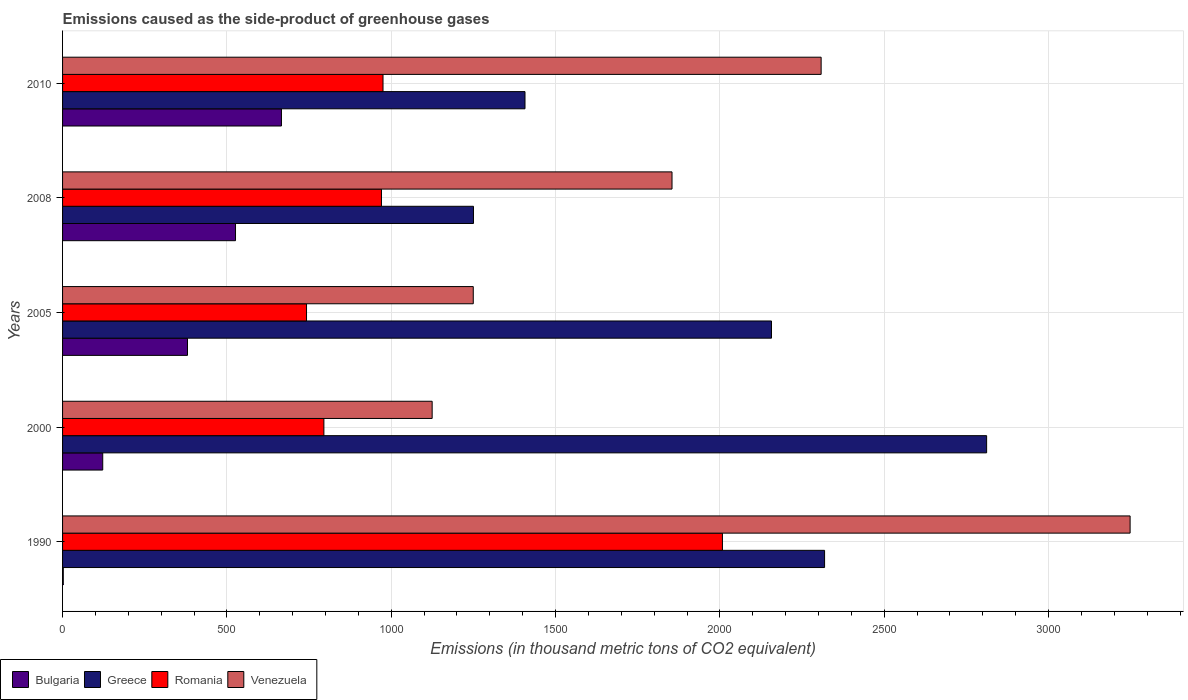How many different coloured bars are there?
Keep it short and to the point. 4. What is the label of the 4th group of bars from the top?
Ensure brevity in your answer.  2000. In how many cases, is the number of bars for a given year not equal to the number of legend labels?
Give a very brief answer. 0. What is the emissions caused as the side-product of greenhouse gases in Greece in 1990?
Offer a very short reply. 2318.5. Across all years, what is the maximum emissions caused as the side-product of greenhouse gases in Greece?
Make the answer very short. 2811.5. Across all years, what is the minimum emissions caused as the side-product of greenhouse gases in Venezuela?
Provide a succinct answer. 1124.5. In which year was the emissions caused as the side-product of greenhouse gases in Bulgaria minimum?
Your answer should be compact. 1990. What is the total emissions caused as the side-product of greenhouse gases in Romania in the graph?
Give a very brief answer. 5490.4. What is the difference between the emissions caused as the side-product of greenhouse gases in Romania in 2000 and that in 2008?
Provide a succinct answer. -175.2. What is the difference between the emissions caused as the side-product of greenhouse gases in Bulgaria in 1990 and the emissions caused as the side-product of greenhouse gases in Venezuela in 2000?
Make the answer very short. -1122.3. What is the average emissions caused as the side-product of greenhouse gases in Venezuela per year?
Offer a very short reply. 1956.9. In the year 2010, what is the difference between the emissions caused as the side-product of greenhouse gases in Romania and emissions caused as the side-product of greenhouse gases in Bulgaria?
Offer a very short reply. 309. What is the ratio of the emissions caused as the side-product of greenhouse gases in Bulgaria in 1990 to that in 2008?
Provide a short and direct response. 0. Is the emissions caused as the side-product of greenhouse gases in Venezuela in 2008 less than that in 2010?
Your answer should be very brief. Yes. What is the difference between the highest and the second highest emissions caused as the side-product of greenhouse gases in Romania?
Offer a very short reply. 1032.7. What is the difference between the highest and the lowest emissions caused as the side-product of greenhouse gases in Bulgaria?
Your answer should be very brief. 663.8. Is the sum of the emissions caused as the side-product of greenhouse gases in Romania in 2005 and 2008 greater than the maximum emissions caused as the side-product of greenhouse gases in Bulgaria across all years?
Ensure brevity in your answer.  Yes. Is it the case that in every year, the sum of the emissions caused as the side-product of greenhouse gases in Venezuela and emissions caused as the side-product of greenhouse gases in Greece is greater than the sum of emissions caused as the side-product of greenhouse gases in Romania and emissions caused as the side-product of greenhouse gases in Bulgaria?
Offer a very short reply. Yes. What does the 3rd bar from the top in 1990 represents?
Ensure brevity in your answer.  Greece. What does the 4th bar from the bottom in 2005 represents?
Offer a very short reply. Venezuela. How many bars are there?
Give a very brief answer. 20. Are all the bars in the graph horizontal?
Offer a very short reply. Yes. Are the values on the major ticks of X-axis written in scientific E-notation?
Keep it short and to the point. No. Where does the legend appear in the graph?
Provide a short and direct response. Bottom left. How many legend labels are there?
Make the answer very short. 4. How are the legend labels stacked?
Your answer should be compact. Horizontal. What is the title of the graph?
Your answer should be compact. Emissions caused as the side-product of greenhouse gases. Does "Fiji" appear as one of the legend labels in the graph?
Offer a terse response. No. What is the label or title of the X-axis?
Your answer should be very brief. Emissions (in thousand metric tons of CO2 equivalent). What is the label or title of the Y-axis?
Give a very brief answer. Years. What is the Emissions (in thousand metric tons of CO2 equivalent) of Greece in 1990?
Your answer should be very brief. 2318.5. What is the Emissions (in thousand metric tons of CO2 equivalent) of Romania in 1990?
Provide a short and direct response. 2007.7. What is the Emissions (in thousand metric tons of CO2 equivalent) of Venezuela in 1990?
Ensure brevity in your answer.  3248.1. What is the Emissions (in thousand metric tons of CO2 equivalent) in Bulgaria in 2000?
Offer a terse response. 122.2. What is the Emissions (in thousand metric tons of CO2 equivalent) in Greece in 2000?
Your response must be concise. 2811.5. What is the Emissions (in thousand metric tons of CO2 equivalent) of Romania in 2000?
Your answer should be compact. 795.1. What is the Emissions (in thousand metric tons of CO2 equivalent) in Venezuela in 2000?
Provide a short and direct response. 1124.5. What is the Emissions (in thousand metric tons of CO2 equivalent) of Bulgaria in 2005?
Make the answer very short. 380.1. What is the Emissions (in thousand metric tons of CO2 equivalent) in Greece in 2005?
Keep it short and to the point. 2157. What is the Emissions (in thousand metric tons of CO2 equivalent) of Romania in 2005?
Your answer should be compact. 742.3. What is the Emissions (in thousand metric tons of CO2 equivalent) in Venezuela in 2005?
Keep it short and to the point. 1249.6. What is the Emissions (in thousand metric tons of CO2 equivalent) of Bulgaria in 2008?
Provide a succinct answer. 526.2. What is the Emissions (in thousand metric tons of CO2 equivalent) in Greece in 2008?
Provide a succinct answer. 1250.2. What is the Emissions (in thousand metric tons of CO2 equivalent) of Romania in 2008?
Offer a terse response. 970.3. What is the Emissions (in thousand metric tons of CO2 equivalent) in Venezuela in 2008?
Your response must be concise. 1854.3. What is the Emissions (in thousand metric tons of CO2 equivalent) in Bulgaria in 2010?
Make the answer very short. 666. What is the Emissions (in thousand metric tons of CO2 equivalent) in Greece in 2010?
Offer a very short reply. 1407. What is the Emissions (in thousand metric tons of CO2 equivalent) of Romania in 2010?
Your answer should be very brief. 975. What is the Emissions (in thousand metric tons of CO2 equivalent) of Venezuela in 2010?
Your response must be concise. 2308. Across all years, what is the maximum Emissions (in thousand metric tons of CO2 equivalent) of Bulgaria?
Keep it short and to the point. 666. Across all years, what is the maximum Emissions (in thousand metric tons of CO2 equivalent) of Greece?
Keep it short and to the point. 2811.5. Across all years, what is the maximum Emissions (in thousand metric tons of CO2 equivalent) in Romania?
Your answer should be compact. 2007.7. Across all years, what is the maximum Emissions (in thousand metric tons of CO2 equivalent) of Venezuela?
Give a very brief answer. 3248.1. Across all years, what is the minimum Emissions (in thousand metric tons of CO2 equivalent) in Greece?
Provide a short and direct response. 1250.2. Across all years, what is the minimum Emissions (in thousand metric tons of CO2 equivalent) of Romania?
Offer a very short reply. 742.3. Across all years, what is the minimum Emissions (in thousand metric tons of CO2 equivalent) of Venezuela?
Offer a very short reply. 1124.5. What is the total Emissions (in thousand metric tons of CO2 equivalent) of Bulgaria in the graph?
Offer a very short reply. 1696.7. What is the total Emissions (in thousand metric tons of CO2 equivalent) in Greece in the graph?
Give a very brief answer. 9944.2. What is the total Emissions (in thousand metric tons of CO2 equivalent) in Romania in the graph?
Offer a very short reply. 5490.4. What is the total Emissions (in thousand metric tons of CO2 equivalent) in Venezuela in the graph?
Make the answer very short. 9784.5. What is the difference between the Emissions (in thousand metric tons of CO2 equivalent) of Bulgaria in 1990 and that in 2000?
Offer a terse response. -120. What is the difference between the Emissions (in thousand metric tons of CO2 equivalent) in Greece in 1990 and that in 2000?
Keep it short and to the point. -493. What is the difference between the Emissions (in thousand metric tons of CO2 equivalent) of Romania in 1990 and that in 2000?
Provide a short and direct response. 1212.6. What is the difference between the Emissions (in thousand metric tons of CO2 equivalent) of Venezuela in 1990 and that in 2000?
Ensure brevity in your answer.  2123.6. What is the difference between the Emissions (in thousand metric tons of CO2 equivalent) in Bulgaria in 1990 and that in 2005?
Provide a succinct answer. -377.9. What is the difference between the Emissions (in thousand metric tons of CO2 equivalent) of Greece in 1990 and that in 2005?
Offer a very short reply. 161.5. What is the difference between the Emissions (in thousand metric tons of CO2 equivalent) of Romania in 1990 and that in 2005?
Your answer should be very brief. 1265.4. What is the difference between the Emissions (in thousand metric tons of CO2 equivalent) in Venezuela in 1990 and that in 2005?
Provide a succinct answer. 1998.5. What is the difference between the Emissions (in thousand metric tons of CO2 equivalent) of Bulgaria in 1990 and that in 2008?
Your answer should be very brief. -524. What is the difference between the Emissions (in thousand metric tons of CO2 equivalent) in Greece in 1990 and that in 2008?
Provide a short and direct response. 1068.3. What is the difference between the Emissions (in thousand metric tons of CO2 equivalent) in Romania in 1990 and that in 2008?
Your answer should be very brief. 1037.4. What is the difference between the Emissions (in thousand metric tons of CO2 equivalent) of Venezuela in 1990 and that in 2008?
Ensure brevity in your answer.  1393.8. What is the difference between the Emissions (in thousand metric tons of CO2 equivalent) in Bulgaria in 1990 and that in 2010?
Ensure brevity in your answer.  -663.8. What is the difference between the Emissions (in thousand metric tons of CO2 equivalent) in Greece in 1990 and that in 2010?
Your answer should be compact. 911.5. What is the difference between the Emissions (in thousand metric tons of CO2 equivalent) in Romania in 1990 and that in 2010?
Offer a very short reply. 1032.7. What is the difference between the Emissions (in thousand metric tons of CO2 equivalent) in Venezuela in 1990 and that in 2010?
Your response must be concise. 940.1. What is the difference between the Emissions (in thousand metric tons of CO2 equivalent) of Bulgaria in 2000 and that in 2005?
Your answer should be very brief. -257.9. What is the difference between the Emissions (in thousand metric tons of CO2 equivalent) of Greece in 2000 and that in 2005?
Provide a short and direct response. 654.5. What is the difference between the Emissions (in thousand metric tons of CO2 equivalent) of Romania in 2000 and that in 2005?
Your response must be concise. 52.8. What is the difference between the Emissions (in thousand metric tons of CO2 equivalent) in Venezuela in 2000 and that in 2005?
Provide a short and direct response. -125.1. What is the difference between the Emissions (in thousand metric tons of CO2 equivalent) of Bulgaria in 2000 and that in 2008?
Provide a succinct answer. -404. What is the difference between the Emissions (in thousand metric tons of CO2 equivalent) in Greece in 2000 and that in 2008?
Your answer should be compact. 1561.3. What is the difference between the Emissions (in thousand metric tons of CO2 equivalent) in Romania in 2000 and that in 2008?
Offer a terse response. -175.2. What is the difference between the Emissions (in thousand metric tons of CO2 equivalent) of Venezuela in 2000 and that in 2008?
Give a very brief answer. -729.8. What is the difference between the Emissions (in thousand metric tons of CO2 equivalent) of Bulgaria in 2000 and that in 2010?
Your answer should be very brief. -543.8. What is the difference between the Emissions (in thousand metric tons of CO2 equivalent) of Greece in 2000 and that in 2010?
Offer a very short reply. 1404.5. What is the difference between the Emissions (in thousand metric tons of CO2 equivalent) of Romania in 2000 and that in 2010?
Offer a very short reply. -179.9. What is the difference between the Emissions (in thousand metric tons of CO2 equivalent) of Venezuela in 2000 and that in 2010?
Keep it short and to the point. -1183.5. What is the difference between the Emissions (in thousand metric tons of CO2 equivalent) of Bulgaria in 2005 and that in 2008?
Give a very brief answer. -146.1. What is the difference between the Emissions (in thousand metric tons of CO2 equivalent) of Greece in 2005 and that in 2008?
Your response must be concise. 906.8. What is the difference between the Emissions (in thousand metric tons of CO2 equivalent) in Romania in 2005 and that in 2008?
Give a very brief answer. -228. What is the difference between the Emissions (in thousand metric tons of CO2 equivalent) in Venezuela in 2005 and that in 2008?
Provide a succinct answer. -604.7. What is the difference between the Emissions (in thousand metric tons of CO2 equivalent) of Bulgaria in 2005 and that in 2010?
Make the answer very short. -285.9. What is the difference between the Emissions (in thousand metric tons of CO2 equivalent) in Greece in 2005 and that in 2010?
Keep it short and to the point. 750. What is the difference between the Emissions (in thousand metric tons of CO2 equivalent) in Romania in 2005 and that in 2010?
Your answer should be very brief. -232.7. What is the difference between the Emissions (in thousand metric tons of CO2 equivalent) in Venezuela in 2005 and that in 2010?
Your answer should be compact. -1058.4. What is the difference between the Emissions (in thousand metric tons of CO2 equivalent) in Bulgaria in 2008 and that in 2010?
Your response must be concise. -139.8. What is the difference between the Emissions (in thousand metric tons of CO2 equivalent) of Greece in 2008 and that in 2010?
Provide a short and direct response. -156.8. What is the difference between the Emissions (in thousand metric tons of CO2 equivalent) in Romania in 2008 and that in 2010?
Provide a short and direct response. -4.7. What is the difference between the Emissions (in thousand metric tons of CO2 equivalent) of Venezuela in 2008 and that in 2010?
Keep it short and to the point. -453.7. What is the difference between the Emissions (in thousand metric tons of CO2 equivalent) of Bulgaria in 1990 and the Emissions (in thousand metric tons of CO2 equivalent) of Greece in 2000?
Keep it short and to the point. -2809.3. What is the difference between the Emissions (in thousand metric tons of CO2 equivalent) of Bulgaria in 1990 and the Emissions (in thousand metric tons of CO2 equivalent) of Romania in 2000?
Your answer should be compact. -792.9. What is the difference between the Emissions (in thousand metric tons of CO2 equivalent) in Bulgaria in 1990 and the Emissions (in thousand metric tons of CO2 equivalent) in Venezuela in 2000?
Your response must be concise. -1122.3. What is the difference between the Emissions (in thousand metric tons of CO2 equivalent) in Greece in 1990 and the Emissions (in thousand metric tons of CO2 equivalent) in Romania in 2000?
Ensure brevity in your answer.  1523.4. What is the difference between the Emissions (in thousand metric tons of CO2 equivalent) of Greece in 1990 and the Emissions (in thousand metric tons of CO2 equivalent) of Venezuela in 2000?
Your response must be concise. 1194. What is the difference between the Emissions (in thousand metric tons of CO2 equivalent) in Romania in 1990 and the Emissions (in thousand metric tons of CO2 equivalent) in Venezuela in 2000?
Keep it short and to the point. 883.2. What is the difference between the Emissions (in thousand metric tons of CO2 equivalent) in Bulgaria in 1990 and the Emissions (in thousand metric tons of CO2 equivalent) in Greece in 2005?
Provide a succinct answer. -2154.8. What is the difference between the Emissions (in thousand metric tons of CO2 equivalent) of Bulgaria in 1990 and the Emissions (in thousand metric tons of CO2 equivalent) of Romania in 2005?
Your answer should be very brief. -740.1. What is the difference between the Emissions (in thousand metric tons of CO2 equivalent) in Bulgaria in 1990 and the Emissions (in thousand metric tons of CO2 equivalent) in Venezuela in 2005?
Your answer should be very brief. -1247.4. What is the difference between the Emissions (in thousand metric tons of CO2 equivalent) of Greece in 1990 and the Emissions (in thousand metric tons of CO2 equivalent) of Romania in 2005?
Provide a succinct answer. 1576.2. What is the difference between the Emissions (in thousand metric tons of CO2 equivalent) in Greece in 1990 and the Emissions (in thousand metric tons of CO2 equivalent) in Venezuela in 2005?
Make the answer very short. 1068.9. What is the difference between the Emissions (in thousand metric tons of CO2 equivalent) in Romania in 1990 and the Emissions (in thousand metric tons of CO2 equivalent) in Venezuela in 2005?
Offer a terse response. 758.1. What is the difference between the Emissions (in thousand metric tons of CO2 equivalent) in Bulgaria in 1990 and the Emissions (in thousand metric tons of CO2 equivalent) in Greece in 2008?
Offer a terse response. -1248. What is the difference between the Emissions (in thousand metric tons of CO2 equivalent) of Bulgaria in 1990 and the Emissions (in thousand metric tons of CO2 equivalent) of Romania in 2008?
Provide a succinct answer. -968.1. What is the difference between the Emissions (in thousand metric tons of CO2 equivalent) in Bulgaria in 1990 and the Emissions (in thousand metric tons of CO2 equivalent) in Venezuela in 2008?
Your answer should be compact. -1852.1. What is the difference between the Emissions (in thousand metric tons of CO2 equivalent) in Greece in 1990 and the Emissions (in thousand metric tons of CO2 equivalent) in Romania in 2008?
Provide a short and direct response. 1348.2. What is the difference between the Emissions (in thousand metric tons of CO2 equivalent) in Greece in 1990 and the Emissions (in thousand metric tons of CO2 equivalent) in Venezuela in 2008?
Make the answer very short. 464.2. What is the difference between the Emissions (in thousand metric tons of CO2 equivalent) in Romania in 1990 and the Emissions (in thousand metric tons of CO2 equivalent) in Venezuela in 2008?
Provide a short and direct response. 153.4. What is the difference between the Emissions (in thousand metric tons of CO2 equivalent) in Bulgaria in 1990 and the Emissions (in thousand metric tons of CO2 equivalent) in Greece in 2010?
Provide a short and direct response. -1404.8. What is the difference between the Emissions (in thousand metric tons of CO2 equivalent) of Bulgaria in 1990 and the Emissions (in thousand metric tons of CO2 equivalent) of Romania in 2010?
Ensure brevity in your answer.  -972.8. What is the difference between the Emissions (in thousand metric tons of CO2 equivalent) of Bulgaria in 1990 and the Emissions (in thousand metric tons of CO2 equivalent) of Venezuela in 2010?
Make the answer very short. -2305.8. What is the difference between the Emissions (in thousand metric tons of CO2 equivalent) of Greece in 1990 and the Emissions (in thousand metric tons of CO2 equivalent) of Romania in 2010?
Offer a very short reply. 1343.5. What is the difference between the Emissions (in thousand metric tons of CO2 equivalent) of Greece in 1990 and the Emissions (in thousand metric tons of CO2 equivalent) of Venezuela in 2010?
Provide a short and direct response. 10.5. What is the difference between the Emissions (in thousand metric tons of CO2 equivalent) of Romania in 1990 and the Emissions (in thousand metric tons of CO2 equivalent) of Venezuela in 2010?
Make the answer very short. -300.3. What is the difference between the Emissions (in thousand metric tons of CO2 equivalent) of Bulgaria in 2000 and the Emissions (in thousand metric tons of CO2 equivalent) of Greece in 2005?
Your answer should be compact. -2034.8. What is the difference between the Emissions (in thousand metric tons of CO2 equivalent) of Bulgaria in 2000 and the Emissions (in thousand metric tons of CO2 equivalent) of Romania in 2005?
Your answer should be compact. -620.1. What is the difference between the Emissions (in thousand metric tons of CO2 equivalent) of Bulgaria in 2000 and the Emissions (in thousand metric tons of CO2 equivalent) of Venezuela in 2005?
Keep it short and to the point. -1127.4. What is the difference between the Emissions (in thousand metric tons of CO2 equivalent) in Greece in 2000 and the Emissions (in thousand metric tons of CO2 equivalent) in Romania in 2005?
Make the answer very short. 2069.2. What is the difference between the Emissions (in thousand metric tons of CO2 equivalent) of Greece in 2000 and the Emissions (in thousand metric tons of CO2 equivalent) of Venezuela in 2005?
Provide a short and direct response. 1561.9. What is the difference between the Emissions (in thousand metric tons of CO2 equivalent) of Romania in 2000 and the Emissions (in thousand metric tons of CO2 equivalent) of Venezuela in 2005?
Offer a very short reply. -454.5. What is the difference between the Emissions (in thousand metric tons of CO2 equivalent) of Bulgaria in 2000 and the Emissions (in thousand metric tons of CO2 equivalent) of Greece in 2008?
Make the answer very short. -1128. What is the difference between the Emissions (in thousand metric tons of CO2 equivalent) in Bulgaria in 2000 and the Emissions (in thousand metric tons of CO2 equivalent) in Romania in 2008?
Provide a short and direct response. -848.1. What is the difference between the Emissions (in thousand metric tons of CO2 equivalent) of Bulgaria in 2000 and the Emissions (in thousand metric tons of CO2 equivalent) of Venezuela in 2008?
Make the answer very short. -1732.1. What is the difference between the Emissions (in thousand metric tons of CO2 equivalent) in Greece in 2000 and the Emissions (in thousand metric tons of CO2 equivalent) in Romania in 2008?
Your response must be concise. 1841.2. What is the difference between the Emissions (in thousand metric tons of CO2 equivalent) of Greece in 2000 and the Emissions (in thousand metric tons of CO2 equivalent) of Venezuela in 2008?
Ensure brevity in your answer.  957.2. What is the difference between the Emissions (in thousand metric tons of CO2 equivalent) of Romania in 2000 and the Emissions (in thousand metric tons of CO2 equivalent) of Venezuela in 2008?
Keep it short and to the point. -1059.2. What is the difference between the Emissions (in thousand metric tons of CO2 equivalent) in Bulgaria in 2000 and the Emissions (in thousand metric tons of CO2 equivalent) in Greece in 2010?
Offer a terse response. -1284.8. What is the difference between the Emissions (in thousand metric tons of CO2 equivalent) in Bulgaria in 2000 and the Emissions (in thousand metric tons of CO2 equivalent) in Romania in 2010?
Your answer should be very brief. -852.8. What is the difference between the Emissions (in thousand metric tons of CO2 equivalent) in Bulgaria in 2000 and the Emissions (in thousand metric tons of CO2 equivalent) in Venezuela in 2010?
Provide a succinct answer. -2185.8. What is the difference between the Emissions (in thousand metric tons of CO2 equivalent) in Greece in 2000 and the Emissions (in thousand metric tons of CO2 equivalent) in Romania in 2010?
Offer a very short reply. 1836.5. What is the difference between the Emissions (in thousand metric tons of CO2 equivalent) in Greece in 2000 and the Emissions (in thousand metric tons of CO2 equivalent) in Venezuela in 2010?
Your answer should be very brief. 503.5. What is the difference between the Emissions (in thousand metric tons of CO2 equivalent) of Romania in 2000 and the Emissions (in thousand metric tons of CO2 equivalent) of Venezuela in 2010?
Your answer should be compact. -1512.9. What is the difference between the Emissions (in thousand metric tons of CO2 equivalent) in Bulgaria in 2005 and the Emissions (in thousand metric tons of CO2 equivalent) in Greece in 2008?
Your answer should be very brief. -870.1. What is the difference between the Emissions (in thousand metric tons of CO2 equivalent) in Bulgaria in 2005 and the Emissions (in thousand metric tons of CO2 equivalent) in Romania in 2008?
Offer a terse response. -590.2. What is the difference between the Emissions (in thousand metric tons of CO2 equivalent) of Bulgaria in 2005 and the Emissions (in thousand metric tons of CO2 equivalent) of Venezuela in 2008?
Your response must be concise. -1474.2. What is the difference between the Emissions (in thousand metric tons of CO2 equivalent) in Greece in 2005 and the Emissions (in thousand metric tons of CO2 equivalent) in Romania in 2008?
Your answer should be very brief. 1186.7. What is the difference between the Emissions (in thousand metric tons of CO2 equivalent) of Greece in 2005 and the Emissions (in thousand metric tons of CO2 equivalent) of Venezuela in 2008?
Give a very brief answer. 302.7. What is the difference between the Emissions (in thousand metric tons of CO2 equivalent) of Romania in 2005 and the Emissions (in thousand metric tons of CO2 equivalent) of Venezuela in 2008?
Offer a terse response. -1112. What is the difference between the Emissions (in thousand metric tons of CO2 equivalent) in Bulgaria in 2005 and the Emissions (in thousand metric tons of CO2 equivalent) in Greece in 2010?
Keep it short and to the point. -1026.9. What is the difference between the Emissions (in thousand metric tons of CO2 equivalent) of Bulgaria in 2005 and the Emissions (in thousand metric tons of CO2 equivalent) of Romania in 2010?
Give a very brief answer. -594.9. What is the difference between the Emissions (in thousand metric tons of CO2 equivalent) in Bulgaria in 2005 and the Emissions (in thousand metric tons of CO2 equivalent) in Venezuela in 2010?
Your response must be concise. -1927.9. What is the difference between the Emissions (in thousand metric tons of CO2 equivalent) of Greece in 2005 and the Emissions (in thousand metric tons of CO2 equivalent) of Romania in 2010?
Give a very brief answer. 1182. What is the difference between the Emissions (in thousand metric tons of CO2 equivalent) of Greece in 2005 and the Emissions (in thousand metric tons of CO2 equivalent) of Venezuela in 2010?
Keep it short and to the point. -151. What is the difference between the Emissions (in thousand metric tons of CO2 equivalent) of Romania in 2005 and the Emissions (in thousand metric tons of CO2 equivalent) of Venezuela in 2010?
Offer a terse response. -1565.7. What is the difference between the Emissions (in thousand metric tons of CO2 equivalent) of Bulgaria in 2008 and the Emissions (in thousand metric tons of CO2 equivalent) of Greece in 2010?
Make the answer very short. -880.8. What is the difference between the Emissions (in thousand metric tons of CO2 equivalent) of Bulgaria in 2008 and the Emissions (in thousand metric tons of CO2 equivalent) of Romania in 2010?
Give a very brief answer. -448.8. What is the difference between the Emissions (in thousand metric tons of CO2 equivalent) of Bulgaria in 2008 and the Emissions (in thousand metric tons of CO2 equivalent) of Venezuela in 2010?
Your response must be concise. -1781.8. What is the difference between the Emissions (in thousand metric tons of CO2 equivalent) in Greece in 2008 and the Emissions (in thousand metric tons of CO2 equivalent) in Romania in 2010?
Give a very brief answer. 275.2. What is the difference between the Emissions (in thousand metric tons of CO2 equivalent) of Greece in 2008 and the Emissions (in thousand metric tons of CO2 equivalent) of Venezuela in 2010?
Provide a succinct answer. -1057.8. What is the difference between the Emissions (in thousand metric tons of CO2 equivalent) in Romania in 2008 and the Emissions (in thousand metric tons of CO2 equivalent) in Venezuela in 2010?
Your answer should be very brief. -1337.7. What is the average Emissions (in thousand metric tons of CO2 equivalent) in Bulgaria per year?
Your answer should be very brief. 339.34. What is the average Emissions (in thousand metric tons of CO2 equivalent) in Greece per year?
Keep it short and to the point. 1988.84. What is the average Emissions (in thousand metric tons of CO2 equivalent) of Romania per year?
Give a very brief answer. 1098.08. What is the average Emissions (in thousand metric tons of CO2 equivalent) in Venezuela per year?
Your response must be concise. 1956.9. In the year 1990, what is the difference between the Emissions (in thousand metric tons of CO2 equivalent) of Bulgaria and Emissions (in thousand metric tons of CO2 equivalent) of Greece?
Offer a very short reply. -2316.3. In the year 1990, what is the difference between the Emissions (in thousand metric tons of CO2 equivalent) of Bulgaria and Emissions (in thousand metric tons of CO2 equivalent) of Romania?
Make the answer very short. -2005.5. In the year 1990, what is the difference between the Emissions (in thousand metric tons of CO2 equivalent) of Bulgaria and Emissions (in thousand metric tons of CO2 equivalent) of Venezuela?
Keep it short and to the point. -3245.9. In the year 1990, what is the difference between the Emissions (in thousand metric tons of CO2 equivalent) of Greece and Emissions (in thousand metric tons of CO2 equivalent) of Romania?
Offer a very short reply. 310.8. In the year 1990, what is the difference between the Emissions (in thousand metric tons of CO2 equivalent) of Greece and Emissions (in thousand metric tons of CO2 equivalent) of Venezuela?
Keep it short and to the point. -929.6. In the year 1990, what is the difference between the Emissions (in thousand metric tons of CO2 equivalent) of Romania and Emissions (in thousand metric tons of CO2 equivalent) of Venezuela?
Your answer should be compact. -1240.4. In the year 2000, what is the difference between the Emissions (in thousand metric tons of CO2 equivalent) in Bulgaria and Emissions (in thousand metric tons of CO2 equivalent) in Greece?
Make the answer very short. -2689.3. In the year 2000, what is the difference between the Emissions (in thousand metric tons of CO2 equivalent) in Bulgaria and Emissions (in thousand metric tons of CO2 equivalent) in Romania?
Give a very brief answer. -672.9. In the year 2000, what is the difference between the Emissions (in thousand metric tons of CO2 equivalent) of Bulgaria and Emissions (in thousand metric tons of CO2 equivalent) of Venezuela?
Provide a succinct answer. -1002.3. In the year 2000, what is the difference between the Emissions (in thousand metric tons of CO2 equivalent) in Greece and Emissions (in thousand metric tons of CO2 equivalent) in Romania?
Your answer should be compact. 2016.4. In the year 2000, what is the difference between the Emissions (in thousand metric tons of CO2 equivalent) in Greece and Emissions (in thousand metric tons of CO2 equivalent) in Venezuela?
Provide a short and direct response. 1687. In the year 2000, what is the difference between the Emissions (in thousand metric tons of CO2 equivalent) of Romania and Emissions (in thousand metric tons of CO2 equivalent) of Venezuela?
Your response must be concise. -329.4. In the year 2005, what is the difference between the Emissions (in thousand metric tons of CO2 equivalent) in Bulgaria and Emissions (in thousand metric tons of CO2 equivalent) in Greece?
Make the answer very short. -1776.9. In the year 2005, what is the difference between the Emissions (in thousand metric tons of CO2 equivalent) of Bulgaria and Emissions (in thousand metric tons of CO2 equivalent) of Romania?
Offer a terse response. -362.2. In the year 2005, what is the difference between the Emissions (in thousand metric tons of CO2 equivalent) of Bulgaria and Emissions (in thousand metric tons of CO2 equivalent) of Venezuela?
Your answer should be compact. -869.5. In the year 2005, what is the difference between the Emissions (in thousand metric tons of CO2 equivalent) in Greece and Emissions (in thousand metric tons of CO2 equivalent) in Romania?
Keep it short and to the point. 1414.7. In the year 2005, what is the difference between the Emissions (in thousand metric tons of CO2 equivalent) in Greece and Emissions (in thousand metric tons of CO2 equivalent) in Venezuela?
Make the answer very short. 907.4. In the year 2005, what is the difference between the Emissions (in thousand metric tons of CO2 equivalent) of Romania and Emissions (in thousand metric tons of CO2 equivalent) of Venezuela?
Offer a very short reply. -507.3. In the year 2008, what is the difference between the Emissions (in thousand metric tons of CO2 equivalent) in Bulgaria and Emissions (in thousand metric tons of CO2 equivalent) in Greece?
Keep it short and to the point. -724. In the year 2008, what is the difference between the Emissions (in thousand metric tons of CO2 equivalent) in Bulgaria and Emissions (in thousand metric tons of CO2 equivalent) in Romania?
Provide a succinct answer. -444.1. In the year 2008, what is the difference between the Emissions (in thousand metric tons of CO2 equivalent) of Bulgaria and Emissions (in thousand metric tons of CO2 equivalent) of Venezuela?
Offer a very short reply. -1328.1. In the year 2008, what is the difference between the Emissions (in thousand metric tons of CO2 equivalent) in Greece and Emissions (in thousand metric tons of CO2 equivalent) in Romania?
Keep it short and to the point. 279.9. In the year 2008, what is the difference between the Emissions (in thousand metric tons of CO2 equivalent) of Greece and Emissions (in thousand metric tons of CO2 equivalent) of Venezuela?
Provide a short and direct response. -604.1. In the year 2008, what is the difference between the Emissions (in thousand metric tons of CO2 equivalent) of Romania and Emissions (in thousand metric tons of CO2 equivalent) of Venezuela?
Ensure brevity in your answer.  -884. In the year 2010, what is the difference between the Emissions (in thousand metric tons of CO2 equivalent) in Bulgaria and Emissions (in thousand metric tons of CO2 equivalent) in Greece?
Give a very brief answer. -741. In the year 2010, what is the difference between the Emissions (in thousand metric tons of CO2 equivalent) in Bulgaria and Emissions (in thousand metric tons of CO2 equivalent) in Romania?
Your answer should be very brief. -309. In the year 2010, what is the difference between the Emissions (in thousand metric tons of CO2 equivalent) of Bulgaria and Emissions (in thousand metric tons of CO2 equivalent) of Venezuela?
Your answer should be very brief. -1642. In the year 2010, what is the difference between the Emissions (in thousand metric tons of CO2 equivalent) of Greece and Emissions (in thousand metric tons of CO2 equivalent) of Romania?
Your response must be concise. 432. In the year 2010, what is the difference between the Emissions (in thousand metric tons of CO2 equivalent) in Greece and Emissions (in thousand metric tons of CO2 equivalent) in Venezuela?
Offer a very short reply. -901. In the year 2010, what is the difference between the Emissions (in thousand metric tons of CO2 equivalent) in Romania and Emissions (in thousand metric tons of CO2 equivalent) in Venezuela?
Your response must be concise. -1333. What is the ratio of the Emissions (in thousand metric tons of CO2 equivalent) of Bulgaria in 1990 to that in 2000?
Your response must be concise. 0.02. What is the ratio of the Emissions (in thousand metric tons of CO2 equivalent) in Greece in 1990 to that in 2000?
Offer a terse response. 0.82. What is the ratio of the Emissions (in thousand metric tons of CO2 equivalent) in Romania in 1990 to that in 2000?
Ensure brevity in your answer.  2.53. What is the ratio of the Emissions (in thousand metric tons of CO2 equivalent) in Venezuela in 1990 to that in 2000?
Ensure brevity in your answer.  2.89. What is the ratio of the Emissions (in thousand metric tons of CO2 equivalent) in Bulgaria in 1990 to that in 2005?
Ensure brevity in your answer.  0.01. What is the ratio of the Emissions (in thousand metric tons of CO2 equivalent) of Greece in 1990 to that in 2005?
Make the answer very short. 1.07. What is the ratio of the Emissions (in thousand metric tons of CO2 equivalent) of Romania in 1990 to that in 2005?
Offer a very short reply. 2.7. What is the ratio of the Emissions (in thousand metric tons of CO2 equivalent) of Venezuela in 1990 to that in 2005?
Provide a succinct answer. 2.6. What is the ratio of the Emissions (in thousand metric tons of CO2 equivalent) in Bulgaria in 1990 to that in 2008?
Your answer should be very brief. 0. What is the ratio of the Emissions (in thousand metric tons of CO2 equivalent) of Greece in 1990 to that in 2008?
Ensure brevity in your answer.  1.85. What is the ratio of the Emissions (in thousand metric tons of CO2 equivalent) of Romania in 1990 to that in 2008?
Provide a succinct answer. 2.07. What is the ratio of the Emissions (in thousand metric tons of CO2 equivalent) in Venezuela in 1990 to that in 2008?
Provide a short and direct response. 1.75. What is the ratio of the Emissions (in thousand metric tons of CO2 equivalent) in Bulgaria in 1990 to that in 2010?
Give a very brief answer. 0. What is the ratio of the Emissions (in thousand metric tons of CO2 equivalent) of Greece in 1990 to that in 2010?
Your answer should be compact. 1.65. What is the ratio of the Emissions (in thousand metric tons of CO2 equivalent) in Romania in 1990 to that in 2010?
Ensure brevity in your answer.  2.06. What is the ratio of the Emissions (in thousand metric tons of CO2 equivalent) in Venezuela in 1990 to that in 2010?
Offer a very short reply. 1.41. What is the ratio of the Emissions (in thousand metric tons of CO2 equivalent) in Bulgaria in 2000 to that in 2005?
Provide a short and direct response. 0.32. What is the ratio of the Emissions (in thousand metric tons of CO2 equivalent) in Greece in 2000 to that in 2005?
Offer a terse response. 1.3. What is the ratio of the Emissions (in thousand metric tons of CO2 equivalent) of Romania in 2000 to that in 2005?
Ensure brevity in your answer.  1.07. What is the ratio of the Emissions (in thousand metric tons of CO2 equivalent) of Venezuela in 2000 to that in 2005?
Provide a succinct answer. 0.9. What is the ratio of the Emissions (in thousand metric tons of CO2 equivalent) in Bulgaria in 2000 to that in 2008?
Your answer should be compact. 0.23. What is the ratio of the Emissions (in thousand metric tons of CO2 equivalent) in Greece in 2000 to that in 2008?
Ensure brevity in your answer.  2.25. What is the ratio of the Emissions (in thousand metric tons of CO2 equivalent) in Romania in 2000 to that in 2008?
Give a very brief answer. 0.82. What is the ratio of the Emissions (in thousand metric tons of CO2 equivalent) of Venezuela in 2000 to that in 2008?
Ensure brevity in your answer.  0.61. What is the ratio of the Emissions (in thousand metric tons of CO2 equivalent) of Bulgaria in 2000 to that in 2010?
Make the answer very short. 0.18. What is the ratio of the Emissions (in thousand metric tons of CO2 equivalent) in Greece in 2000 to that in 2010?
Your answer should be compact. 2. What is the ratio of the Emissions (in thousand metric tons of CO2 equivalent) in Romania in 2000 to that in 2010?
Give a very brief answer. 0.82. What is the ratio of the Emissions (in thousand metric tons of CO2 equivalent) of Venezuela in 2000 to that in 2010?
Your answer should be very brief. 0.49. What is the ratio of the Emissions (in thousand metric tons of CO2 equivalent) of Bulgaria in 2005 to that in 2008?
Make the answer very short. 0.72. What is the ratio of the Emissions (in thousand metric tons of CO2 equivalent) in Greece in 2005 to that in 2008?
Your response must be concise. 1.73. What is the ratio of the Emissions (in thousand metric tons of CO2 equivalent) in Romania in 2005 to that in 2008?
Provide a succinct answer. 0.77. What is the ratio of the Emissions (in thousand metric tons of CO2 equivalent) of Venezuela in 2005 to that in 2008?
Your answer should be compact. 0.67. What is the ratio of the Emissions (in thousand metric tons of CO2 equivalent) of Bulgaria in 2005 to that in 2010?
Offer a terse response. 0.57. What is the ratio of the Emissions (in thousand metric tons of CO2 equivalent) of Greece in 2005 to that in 2010?
Provide a succinct answer. 1.53. What is the ratio of the Emissions (in thousand metric tons of CO2 equivalent) of Romania in 2005 to that in 2010?
Give a very brief answer. 0.76. What is the ratio of the Emissions (in thousand metric tons of CO2 equivalent) in Venezuela in 2005 to that in 2010?
Keep it short and to the point. 0.54. What is the ratio of the Emissions (in thousand metric tons of CO2 equivalent) of Bulgaria in 2008 to that in 2010?
Your answer should be compact. 0.79. What is the ratio of the Emissions (in thousand metric tons of CO2 equivalent) in Greece in 2008 to that in 2010?
Your answer should be very brief. 0.89. What is the ratio of the Emissions (in thousand metric tons of CO2 equivalent) in Romania in 2008 to that in 2010?
Your answer should be very brief. 1. What is the ratio of the Emissions (in thousand metric tons of CO2 equivalent) of Venezuela in 2008 to that in 2010?
Keep it short and to the point. 0.8. What is the difference between the highest and the second highest Emissions (in thousand metric tons of CO2 equivalent) of Bulgaria?
Make the answer very short. 139.8. What is the difference between the highest and the second highest Emissions (in thousand metric tons of CO2 equivalent) in Greece?
Give a very brief answer. 493. What is the difference between the highest and the second highest Emissions (in thousand metric tons of CO2 equivalent) of Romania?
Your answer should be very brief. 1032.7. What is the difference between the highest and the second highest Emissions (in thousand metric tons of CO2 equivalent) in Venezuela?
Keep it short and to the point. 940.1. What is the difference between the highest and the lowest Emissions (in thousand metric tons of CO2 equivalent) of Bulgaria?
Offer a very short reply. 663.8. What is the difference between the highest and the lowest Emissions (in thousand metric tons of CO2 equivalent) in Greece?
Your answer should be compact. 1561.3. What is the difference between the highest and the lowest Emissions (in thousand metric tons of CO2 equivalent) in Romania?
Your answer should be compact. 1265.4. What is the difference between the highest and the lowest Emissions (in thousand metric tons of CO2 equivalent) of Venezuela?
Offer a very short reply. 2123.6. 